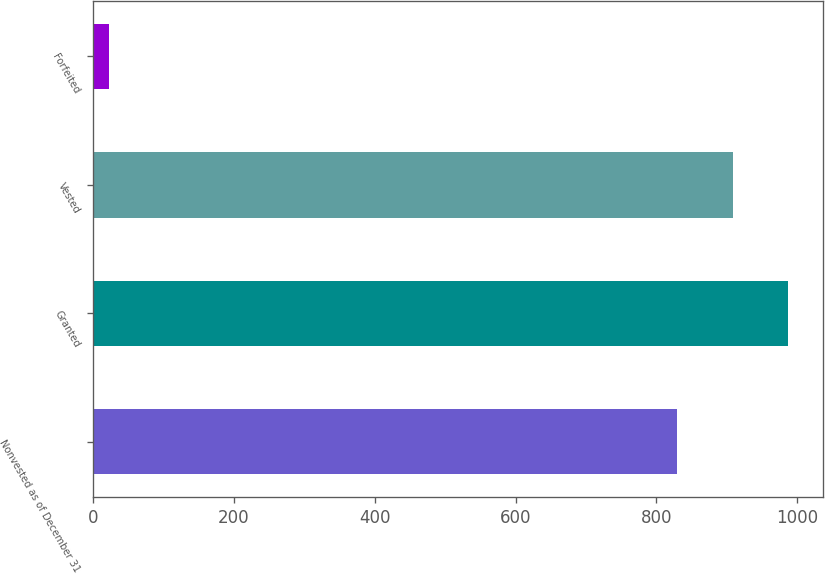Convert chart. <chart><loc_0><loc_0><loc_500><loc_500><bar_chart><fcel>Nonvested as of December 31<fcel>Granted<fcel>Vested<fcel>Forfeited<nl><fcel>829.7<fcel>987.1<fcel>908.4<fcel>22<nl></chart> 